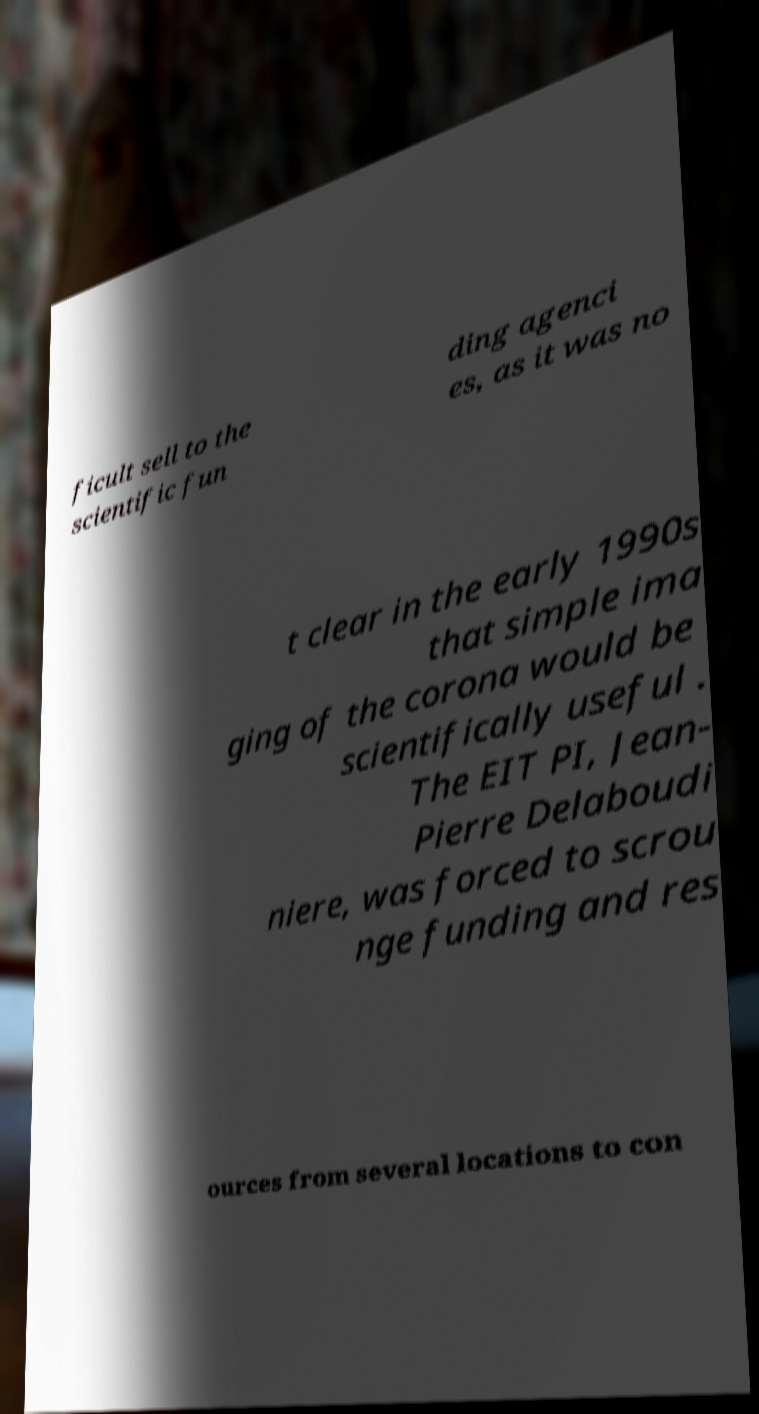There's text embedded in this image that I need extracted. Can you transcribe it verbatim? ficult sell to the scientific fun ding agenci es, as it was no t clear in the early 1990s that simple ima ging of the corona would be scientifically useful . The EIT PI, Jean- Pierre Delaboudi niere, was forced to scrou nge funding and res ources from several locations to con 